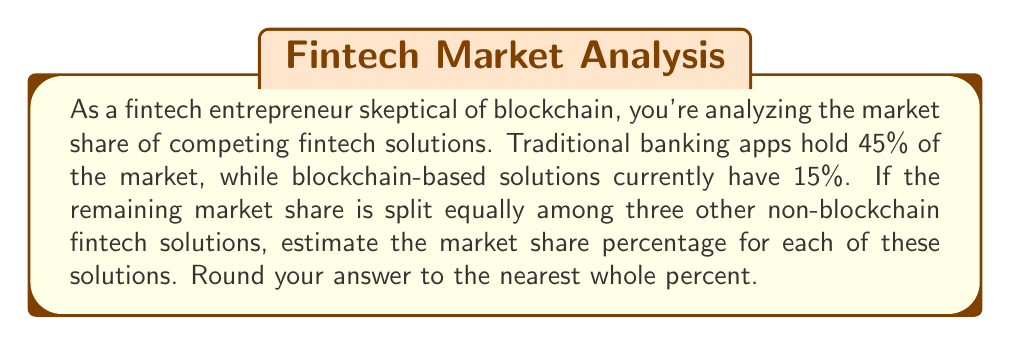Provide a solution to this math problem. To solve this problem, we'll follow these steps:

1. Calculate the total market share held by traditional banking apps and blockchain solutions:
   $45\% + 15\% = 60\%$

2. Determine the remaining market share:
   $100\% - 60\% = 40\%$

3. Divide the remaining market share equally among the three other non-blockchain fintech solutions:
   $\frac{40\%}{3} = 13.33\%$

4. Round the result to the nearest whole percent:
   $13.33\%$ rounds to $13\%$

Therefore, each of the three non-blockchain fintech solutions has an estimated market share of 13%.
Answer: $13\%$ 